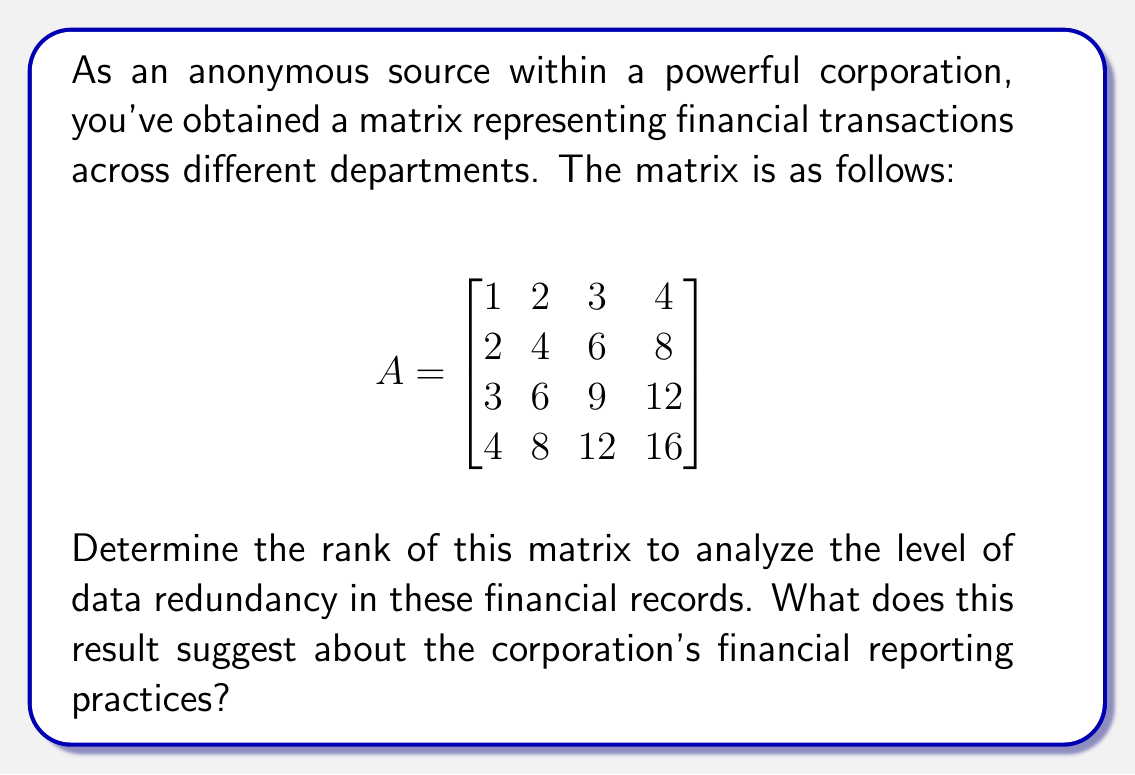Show me your answer to this math problem. To determine the rank of the matrix, we need to follow these steps:

1) First, let's convert the matrix to reduced row echelon form (RREF) using Gaussian elimination:

$$
\begin{bmatrix}
1 & 2 & 3 & 4 \\
2 & 4 & 6 & 8 \\
3 & 6 & 9 & 12 \\
4 & 8 & 12 & 16
\end{bmatrix} \rightarrow
\begin{bmatrix}
1 & 2 & 3 & 4 \\
0 & 0 & 0 & 0 \\
0 & 0 & 0 & 0 \\
0 & 0 & 0 & 0
\end{bmatrix}
$$

2) The rank of a matrix is equal to the number of non-zero rows in its RREF.

3) In this case, we can see that there is only one non-zero row in the RREF.

4) Therefore, the rank of the matrix is 1.

5) This result suggests a high level of data redundancy in the financial records. All rows are linear multiples of the first row, indicating that the data in each row can be derived from the data in any other row.

6) In the context of financial reporting, this could suggest:
   - Possible manipulation of financial data
   - Lack of diversity in financial transactions across departments
   - Potentially fabricated or copied data to inflate transaction volumes

7) The low rank (1) compared to the size of the matrix (4x4) indicates that there's significantly less unique information than what appears at first glance, raising red flags about the authenticity and integrity of the financial records.
Answer: Rank = 1; suggests high data redundancy and potential financial reporting irregularities. 